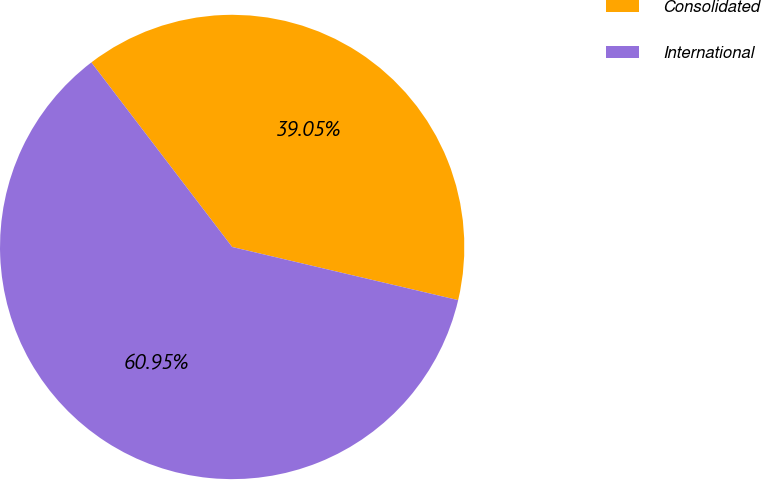Convert chart to OTSL. <chart><loc_0><loc_0><loc_500><loc_500><pie_chart><fcel>Consolidated<fcel>International<nl><fcel>39.05%<fcel>60.95%<nl></chart> 